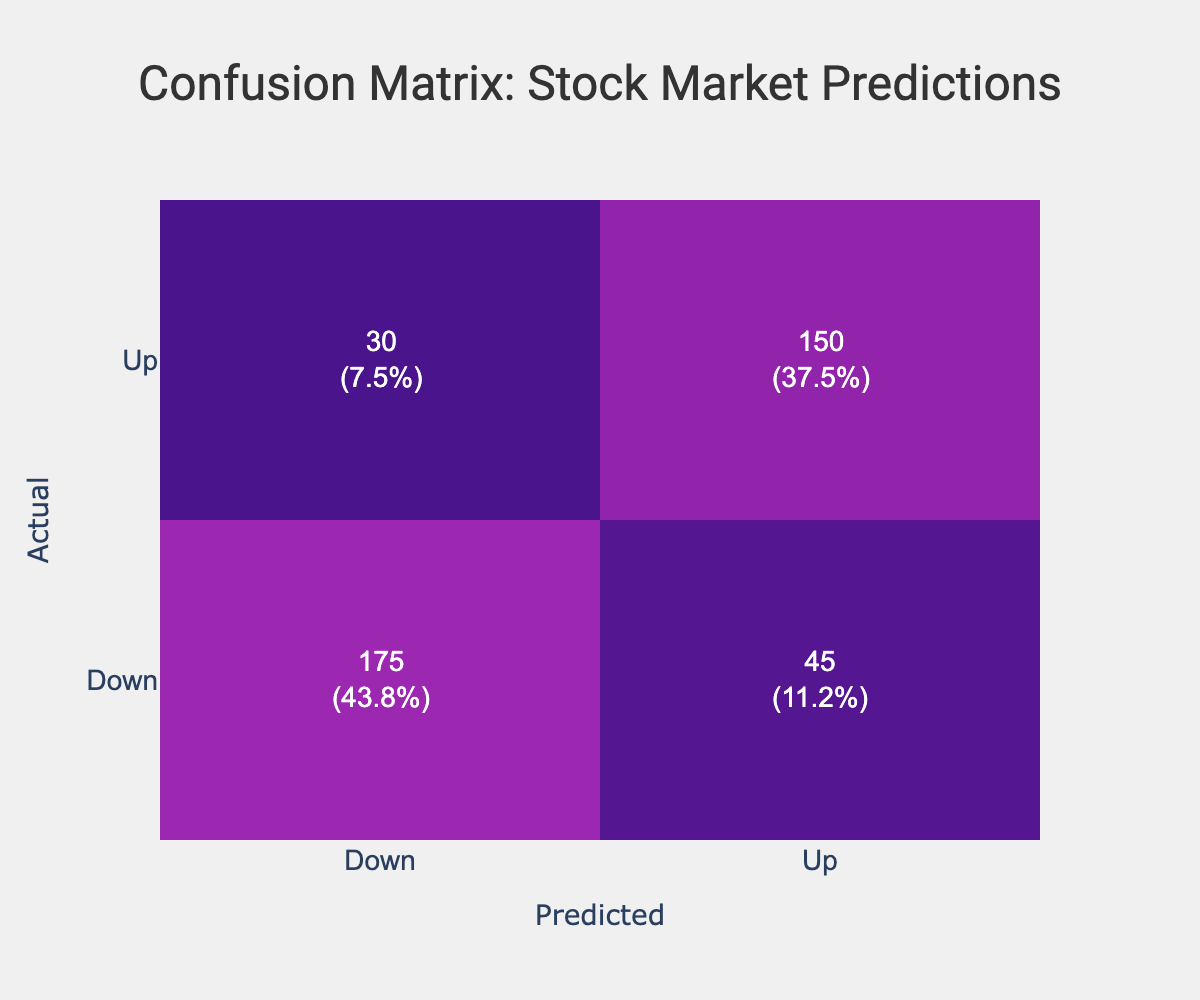What is the total number of predictions made? To find the total number of predictions made, we need to sum up all the counts in the confusion matrix: 150 (Up, Up) + 30 (Up, Down) + 45 (Down, Up) + 175 (Down, Down) = 400.
Answer: 400 How many times was the stock market predicted to go Up when it actually went Down? We look for the count in the row where the actual price direction is Down and the predicted direction is Up. This value is 45.
Answer: 45 What percentage of predictions were correct? The number of correct predictions is the sum of True Positives (150) and True Negatives (175), which is 325. To find the percentage, we divide this by the total number of predictions (400) and multiply by 100. ((325/400) * 100) = 81.25%.
Answer: 81.25% Did the model predict more Down directions than Up directions in total? To analyze this, we sum the predictions for Up (150 + 30 = 180) and Down (45 + 175 = 220). Since 220 is greater than 180, the answer is yes.
Answer: Yes What is the difference between the number of Up predictions and Down predictions? We calculate the total Up predictions (150 + 30 = 180) and total Down predictions (45 + 175 = 220). The difference is 220 - 180 = 40.
Answer: 40 What is the average number of correct predictions per category (Up and Down)? For Up, the correct predictions are 150 (Up, Up). For Down, it's 175 (Down, Down). The total correct predictions are 325. There are two categories (Up, Down). Thus, the average is 325/2 = 162.5.
Answer: 162.5 What fraction of predictions were Wrong predictions? We calculate Wrong predictions by summing the counts for false predictions: Up predicted Down (30) and Down predicted Up (45). The total number of wrong predictions is 30 + 45 = 75. The fraction of wrong predictions is 75/400 = 0.1875.
Answer: 0.1875 How many predictions were made for the direction Down? To calculate the number of predictions made for Down, we add the counts for both predicted outcomes when the actual direction is Down: 45 (Down, Up) + 175 (Down, Down) = 220.
Answer: 220 What is the ratio of correct Up predictions to total Up predictions? We have 150 correct Up predictions (Up, Up) out of a total of 180 predicted Up (150 + 30). Therefore, the ratio is 150/180, which simplifies to 5/6.
Answer: 5/6 